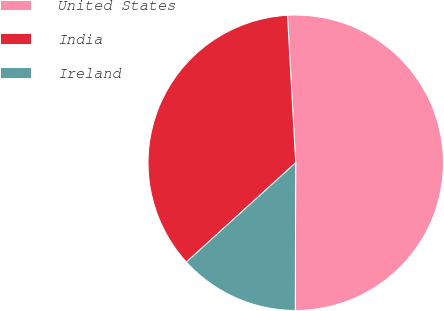Convert chart to OTSL. <chart><loc_0><loc_0><loc_500><loc_500><pie_chart><fcel>United States<fcel>India<fcel>Ireland<nl><fcel>50.94%<fcel>35.85%<fcel>13.21%<nl></chart> 